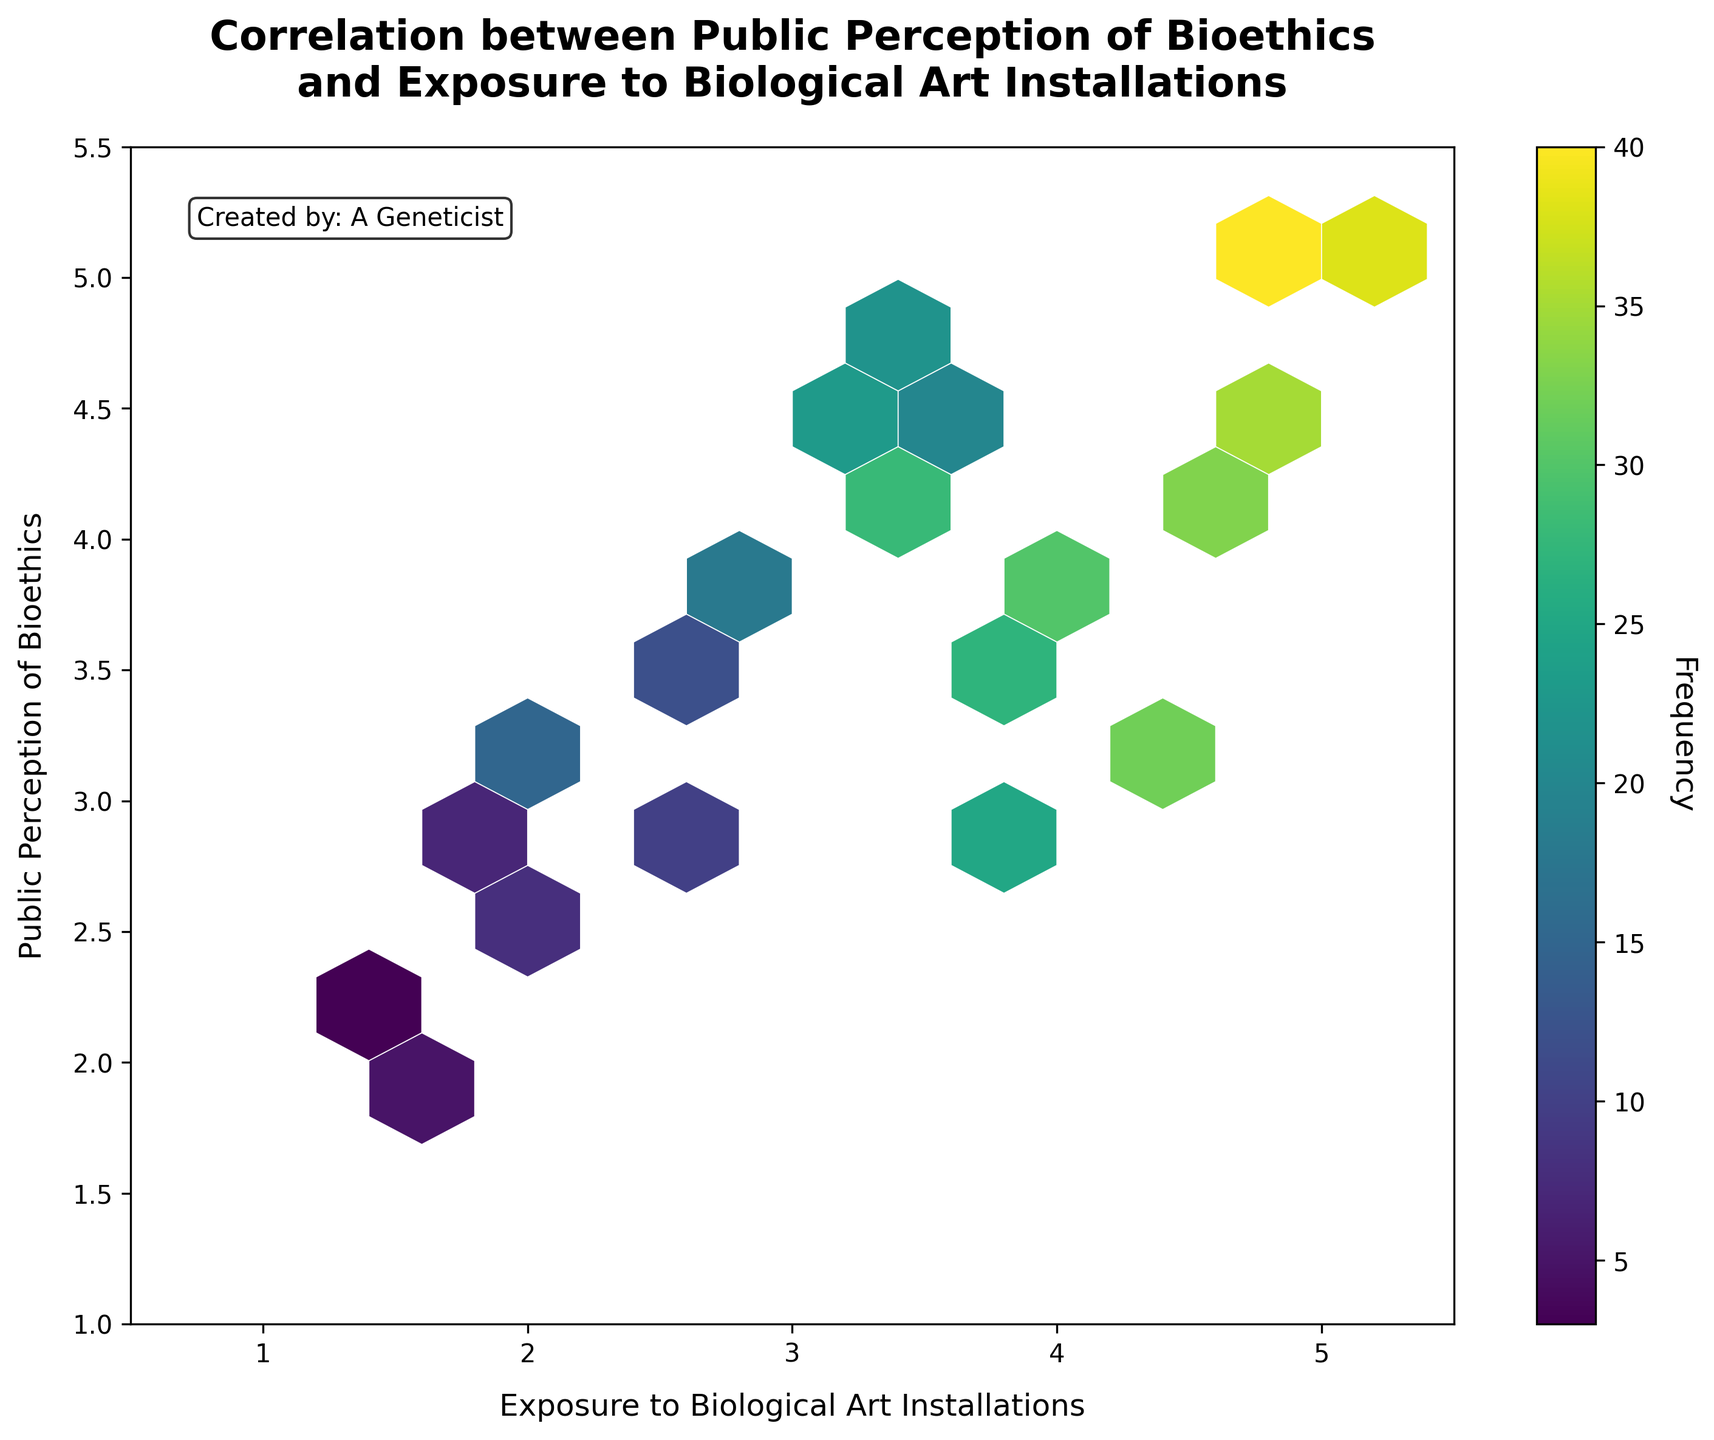what is the title of the figure? The title is located at the top of the plot and describes the main focus of the figure. It reads "Correlation between Public Perception of Bioethics and Exposure to Biological Art Installations".
Answer: Correlation between Public Perception of Bioethics and Exposure to Biological Art Installations What are the labels of the x and y-axes? The labels of the x and y-axes describe the variables represented on each axis. The x-axis is labeled "Exposure to Biological Art Installations" and the y-axis is labeled "Public Perception of Bioethics".
Answer: x-axis: Exposure to Biological Art Installations; y-axis: Public Perception of Bioethics Which color scheme is used in the hexbin plot? The color scheme indicates the density of data points. The plot uses a viridis color map which ranges from dark purple (low density) to bright yellow (high density).
Answer: viridis What is the frequency range represented by the color bar? The color bar indicates the range of data point frequencies. It ranges from the minimum frequency to the maximum frequency observed in the plot. In this case, the frequency ranges from 3 (minimum) to 40 (maximum).
Answer: 3 to 40 How does the frequency of data points change with an increase in exposure to biological art installations? Observing the hexbin plot, the density of hexagons indicates that frequencies generally increase with higher exposure values. Specifically, brighter yellow hexagons appear towards the upper range of exposure values.
Answer: Frequencies generally increase Which hexagon represents the highest density of data points? The hexagon with the brightest yellow color represents the highest density of data points. According to the color bar, this corresponds to the frequency of 40. The coordinates for this hexagon are around (4.7, 5.1).
Answer: Around (4.7, 5.1) What is the approximate exposure value where the highest frequency of public perception of bioethics is observed? Locate the hexagon with the highest frequency (brightest yellow) and observe the x-axis value. The highest frequency is observed at an exposure value of around 4.7.
Answer: Around 4.7 Are there any hexagons with very low frequencies and where are they located? The hexagons with the darkest purple color indicate the lowest frequencies. These are located in the lower left part of the plot, around coordinates (1.2, 2.2) and (1.5, 1.9).
Answer: Around (1.2, 2.2) and (1.5, 1.9) Is there a trend visible between exposure to biological art installations and public perception of bioethics? By observing the distribution of hexagons, a moderate positive correlation is visible, where higher exposure values tend to align with higher public perception values.
Answer: Moderate positive correlation What grid size and other styling details are used to generate this hexbin plot? The grid size determines the number of hexagons the data is binned into. This plot uses a gridsize of 10 with white edge colors and linewidths of 0.4 to separate hexagons visibly.
Answer: Gridsize of 10, white edge colors, linewidths of 0.4 